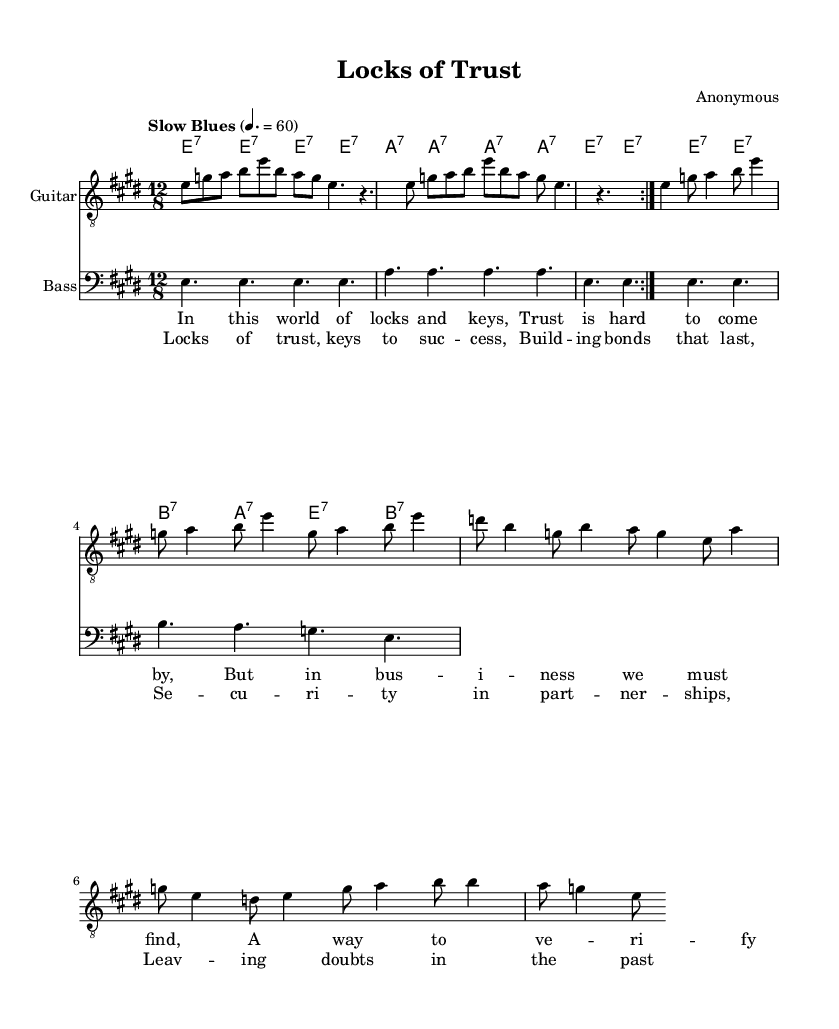What is the key signature of this music? The key signature indicates that the piece is in E major, which has four sharps (F#, C#, G#, D#). This can be determined by looking at the key signature indicated at the beginning of the sheet music.
Answer: E major What is the time signature of this music? The time signature is 12/8, which means there are 12 eighth notes in each measure. This is noted at the beginning of the music and suggests a swing feel typical in blues music.
Answer: 12/8 What is the tempo marking for this piece? The tempo marking is "Slow Blues," which indicates a slower, relaxed tempo typical of the blues genre. This gives a feel for how the song should be played.
Answer: Slow Blues How many times is the first section of the guitar part repeated? The guitar part has a repeat sign (volta) indicating that it should be played twice before moving on. Thus, the first section will be played two times.
Answer: 2 What chords are used in the chorus of the song? The chorus contains the chords E7, A7, and B7 repeated in the progression, which are typical in blues music. The specific chords can be found in the chord names section under the chorus lyrics.
Answer: E7, A7, B7 What is the theme explored in the lyrics of the song? The lyrics discuss trust and security in business relationships, emphasizing the importance of building bonds that last and leaving doubts behind. This thematic exploration is evident in both the verses and chorus.
Answer: Trust and security Which instrument plays the bass part in this music? The bass part is specifically notated, and by looking at the staff labeled 'Bass,' we can confirm that a bass guitar (or similar instrument) plays this part.
Answer: Bass guitar 